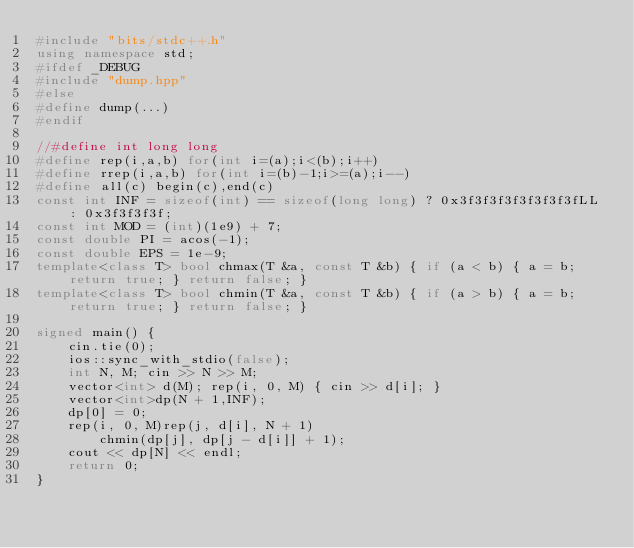<code> <loc_0><loc_0><loc_500><loc_500><_C++_>#include "bits/stdc++.h"
using namespace std;
#ifdef _DEBUG
#include "dump.hpp"
#else
#define dump(...)
#endif

//#define int long long
#define rep(i,a,b) for(int i=(a);i<(b);i++)
#define rrep(i,a,b) for(int i=(b)-1;i>=(a);i--)
#define all(c) begin(c),end(c)
const int INF = sizeof(int) == sizeof(long long) ? 0x3f3f3f3f3f3f3f3fLL : 0x3f3f3f3f;
const int MOD = (int)(1e9) + 7;
const double PI = acos(-1);
const double EPS = 1e-9;
template<class T> bool chmax(T &a, const T &b) { if (a < b) { a = b; return true; } return false; }
template<class T> bool chmin(T &a, const T &b) { if (a > b) { a = b; return true; } return false; }

signed main() {
	cin.tie(0);
	ios::sync_with_stdio(false);
	int N, M; cin >> N >> M;
	vector<int> d(M); rep(i, 0, M) { cin >> d[i]; }
	vector<int>dp(N + 1,INF);
	dp[0] = 0;
	rep(i, 0, M)rep(j, d[i], N + 1)
		chmin(dp[j], dp[j - d[i]] + 1);
	cout << dp[N] << endl;
	return 0;
}</code> 